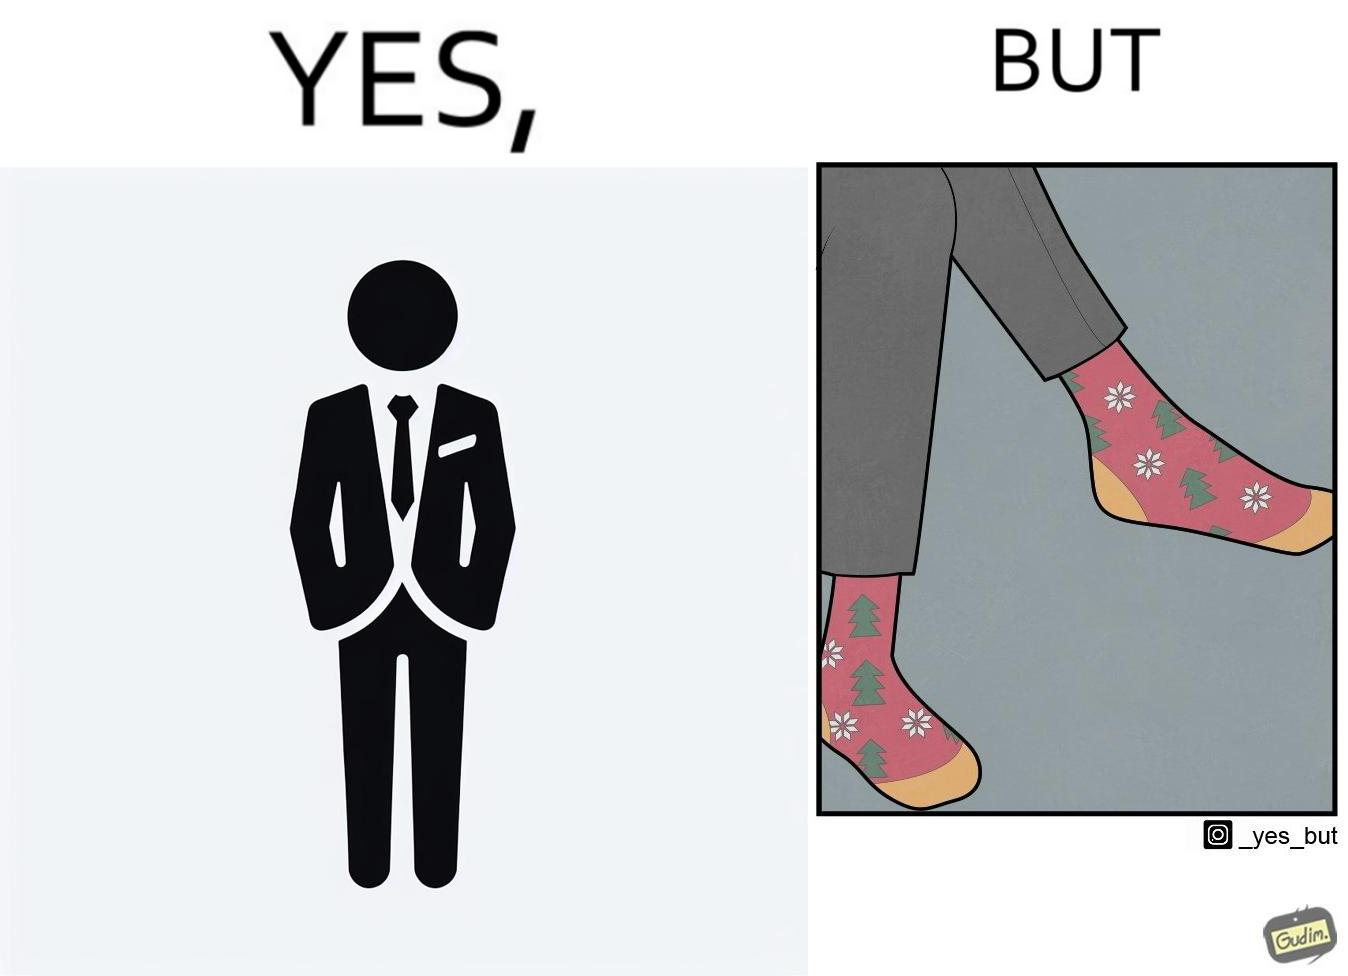Is this image satirical or non-satirical? Yes, this image is satirical. 